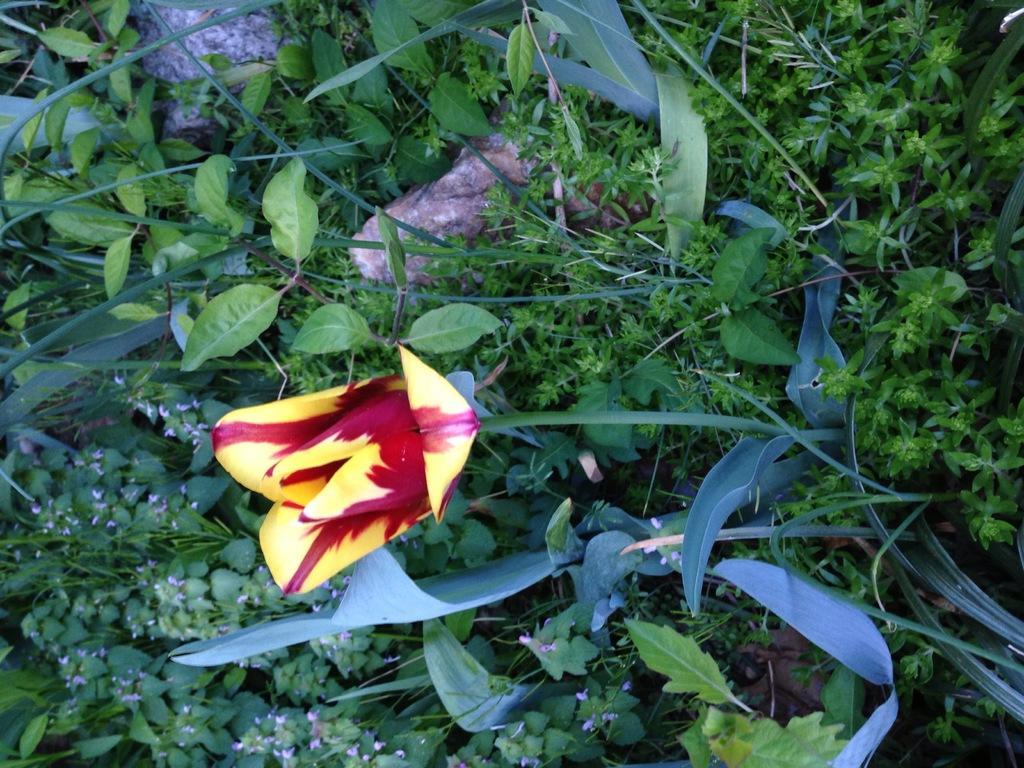Could you give a brief overview of what you see in this image? In this image there are grass and stones. There is a plant. There is a flower. 